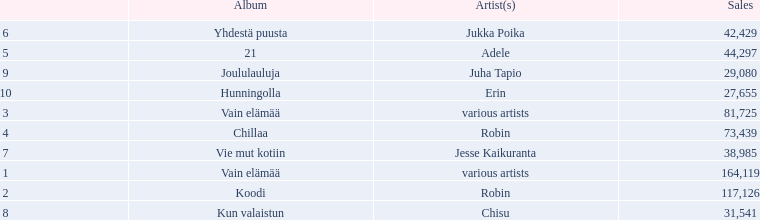What sales does adele have? 44,297. What sales does chisu have? 31,541. Could you parse the entire table? {'header': ['', 'Album', 'Artist(s)', 'Sales'], 'rows': [['6', 'Yhdestä puusta', 'Jukka Poika', '42,429'], ['5', '21', 'Adele', '44,297'], ['9', 'Joululauluja', 'Juha Tapio', '29,080'], ['10', 'Hunningolla', 'Erin', '27,655'], ['3', 'Vain elämää', 'various artists', '81,725'], ['4', 'Chillaa', 'Robin', '73,439'], ['7', 'Vie mut kotiin', 'Jesse Kaikuranta', '38,985'], ['1', 'Vain elämää', 'various artists', '164,119'], ['2', 'Koodi', 'Robin', '117,126'], ['8', 'Kun valaistun', 'Chisu', '31,541']]} Which of these numbers are higher? 44,297. Who has this number of sales? Adele. 